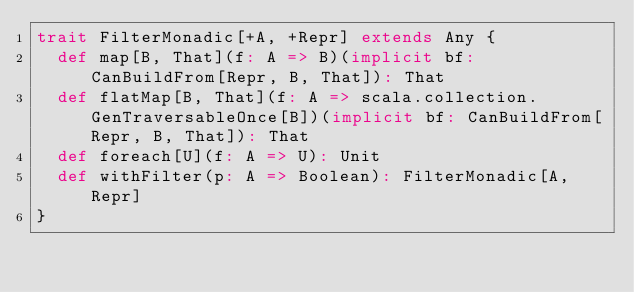Convert code to text. <code><loc_0><loc_0><loc_500><loc_500><_Scala_>trait FilterMonadic[+A, +Repr] extends Any {
  def map[B, That](f: A => B)(implicit bf: CanBuildFrom[Repr, B, That]): That
  def flatMap[B, That](f: A => scala.collection.GenTraversableOnce[B])(implicit bf: CanBuildFrom[Repr, B, That]): That
  def foreach[U](f: A => U): Unit
  def withFilter(p: A => Boolean): FilterMonadic[A, Repr]
}
</code> 